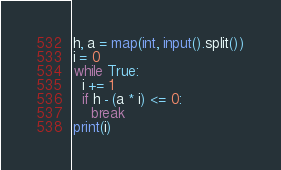Convert code to text. <code><loc_0><loc_0><loc_500><loc_500><_Python_>h, a = map(int, input().split())
i = 0
while True:
  i += 1
  if h - (a * i) <= 0:
    break
print(i)</code> 